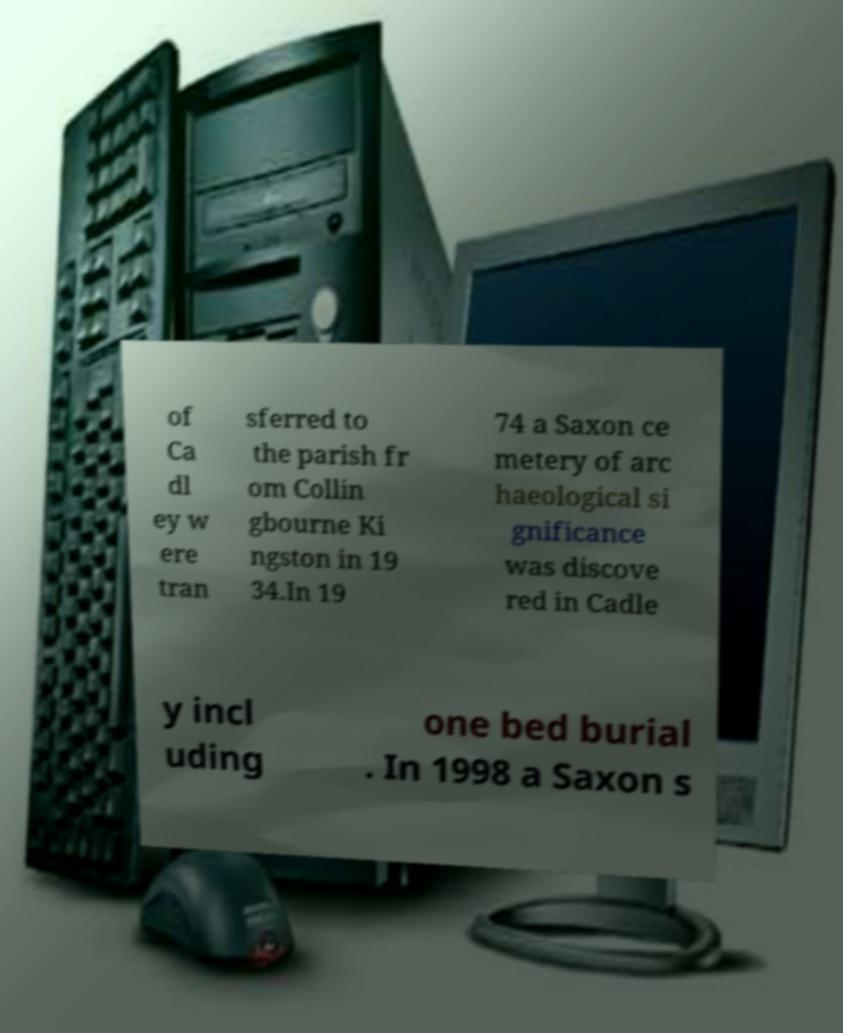Could you assist in decoding the text presented in this image and type it out clearly? of Ca dl ey w ere tran sferred to the parish fr om Collin gbourne Ki ngston in 19 34.In 19 74 a Saxon ce metery of arc haeological si gnificance was discove red in Cadle y incl uding one bed burial . In 1998 a Saxon s 